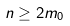<formula> <loc_0><loc_0><loc_500><loc_500>n \geq 2 m _ { 0 }</formula> 